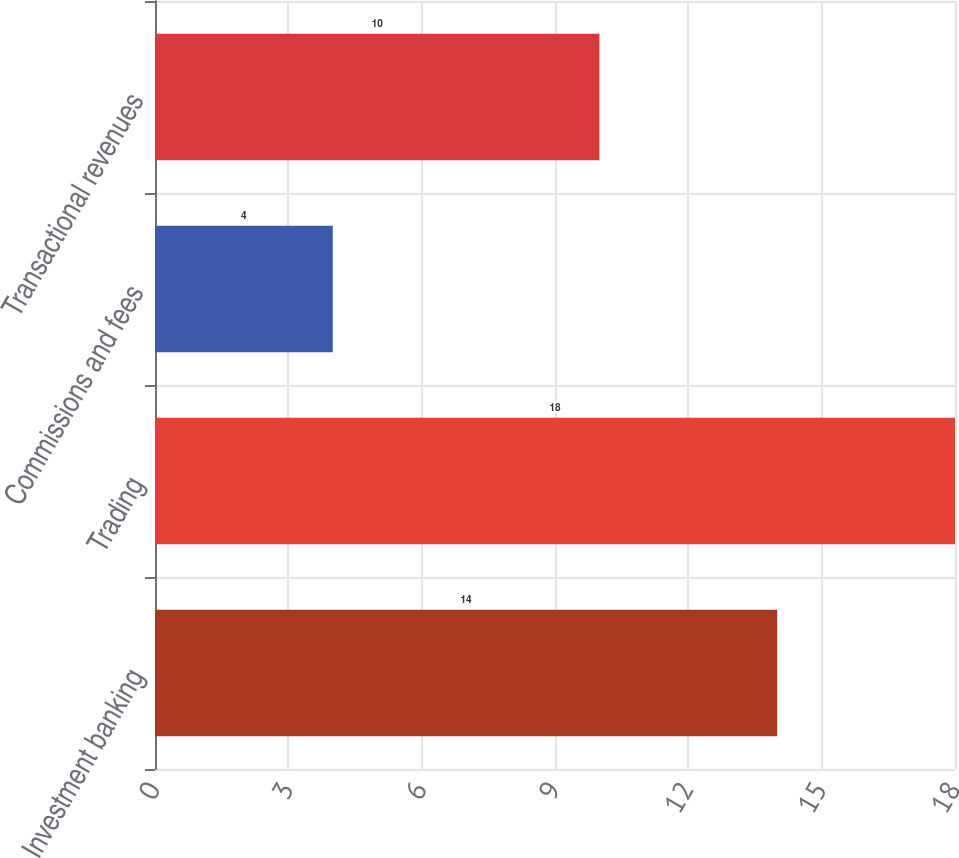Convert chart to OTSL. <chart><loc_0><loc_0><loc_500><loc_500><bar_chart><fcel>Investment banking<fcel>Trading<fcel>Commissions and fees<fcel>Transactional revenues<nl><fcel>14<fcel>18<fcel>4<fcel>10<nl></chart> 